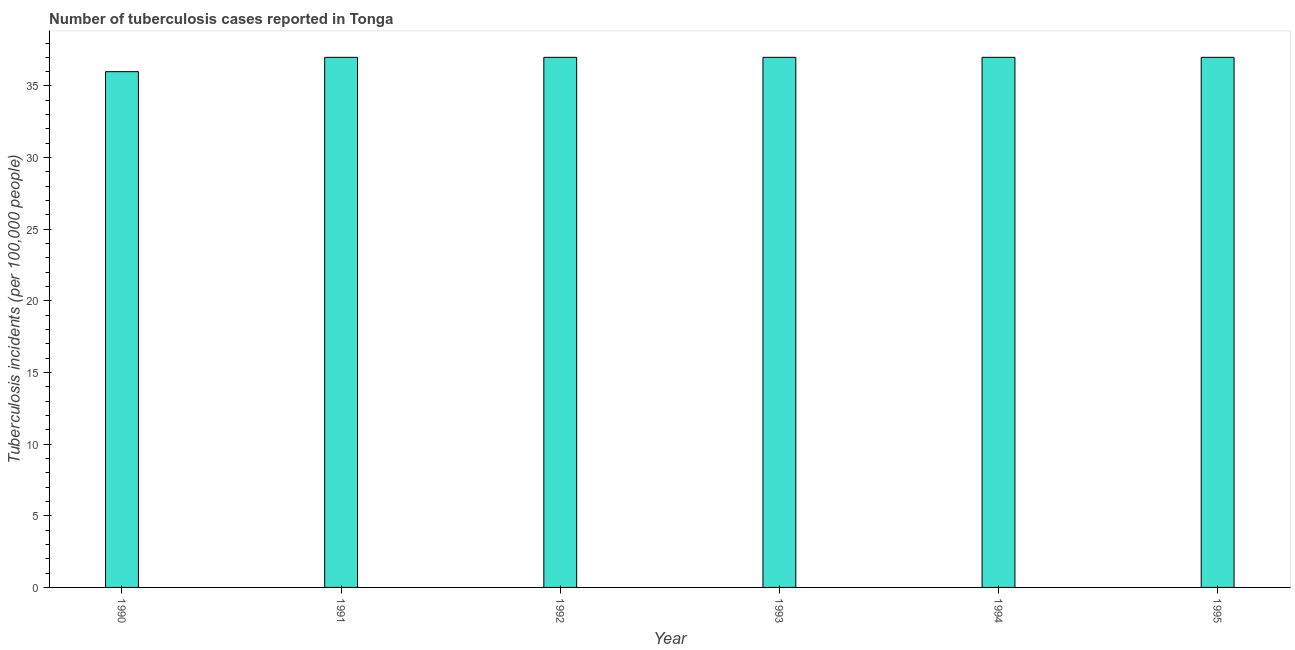Does the graph contain any zero values?
Ensure brevity in your answer.  No. What is the title of the graph?
Provide a short and direct response. Number of tuberculosis cases reported in Tonga. What is the label or title of the X-axis?
Provide a succinct answer. Year. What is the label or title of the Y-axis?
Offer a terse response. Tuberculosis incidents (per 100,0 people). Across all years, what is the minimum number of tuberculosis incidents?
Offer a terse response. 36. In which year was the number of tuberculosis incidents maximum?
Your response must be concise. 1991. In which year was the number of tuberculosis incidents minimum?
Your answer should be compact. 1990. What is the sum of the number of tuberculosis incidents?
Provide a succinct answer. 221. What is the difference between the number of tuberculosis incidents in 1990 and 1991?
Keep it short and to the point. -1. What is the average number of tuberculosis incidents per year?
Keep it short and to the point. 36. Do a majority of the years between 1991 and 1994 (inclusive) have number of tuberculosis incidents greater than 9 ?
Make the answer very short. Yes. What is the difference between the highest and the second highest number of tuberculosis incidents?
Offer a very short reply. 0. Is the sum of the number of tuberculosis incidents in 1990 and 1991 greater than the maximum number of tuberculosis incidents across all years?
Your answer should be very brief. Yes. In how many years, is the number of tuberculosis incidents greater than the average number of tuberculosis incidents taken over all years?
Give a very brief answer. 5. How many years are there in the graph?
Your answer should be compact. 6. Are the values on the major ticks of Y-axis written in scientific E-notation?
Provide a short and direct response. No. What is the Tuberculosis incidents (per 100,000 people) in 1992?
Offer a terse response. 37. What is the Tuberculosis incidents (per 100,000 people) in 1994?
Your response must be concise. 37. What is the difference between the Tuberculosis incidents (per 100,000 people) in 1990 and 1993?
Provide a succinct answer. -1. What is the difference between the Tuberculosis incidents (per 100,000 people) in 1991 and 1993?
Make the answer very short. 0. What is the difference between the Tuberculosis incidents (per 100,000 people) in 1991 and 1995?
Keep it short and to the point. 0. What is the difference between the Tuberculosis incidents (per 100,000 people) in 1992 and 1993?
Your answer should be compact. 0. What is the difference between the Tuberculosis incidents (per 100,000 people) in 1993 and 1994?
Give a very brief answer. 0. What is the difference between the Tuberculosis incidents (per 100,000 people) in 1994 and 1995?
Offer a very short reply. 0. What is the ratio of the Tuberculosis incidents (per 100,000 people) in 1990 to that in 1994?
Your response must be concise. 0.97. What is the ratio of the Tuberculosis incidents (per 100,000 people) in 1990 to that in 1995?
Make the answer very short. 0.97. What is the ratio of the Tuberculosis incidents (per 100,000 people) in 1991 to that in 1992?
Provide a short and direct response. 1. What is the ratio of the Tuberculosis incidents (per 100,000 people) in 1991 to that in 1993?
Provide a succinct answer. 1. What is the ratio of the Tuberculosis incidents (per 100,000 people) in 1991 to that in 1994?
Give a very brief answer. 1. What is the ratio of the Tuberculosis incidents (per 100,000 people) in 1991 to that in 1995?
Provide a succinct answer. 1. What is the ratio of the Tuberculosis incidents (per 100,000 people) in 1992 to that in 1993?
Your answer should be very brief. 1. What is the ratio of the Tuberculosis incidents (per 100,000 people) in 1992 to that in 1994?
Offer a terse response. 1. What is the ratio of the Tuberculosis incidents (per 100,000 people) in 1993 to that in 1994?
Make the answer very short. 1. 